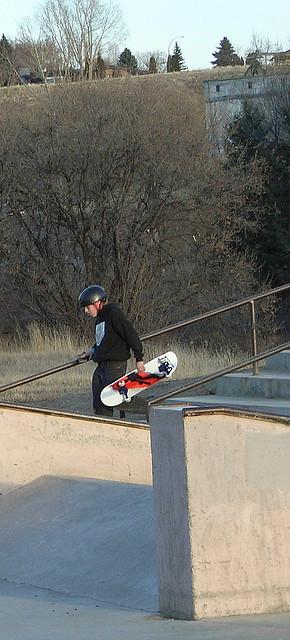What color is his skateboard?
Concise answer only. White. Is he wearing a helmet?
Keep it brief. Yes. Is he doing a trick right now?
Quick response, please. No. 